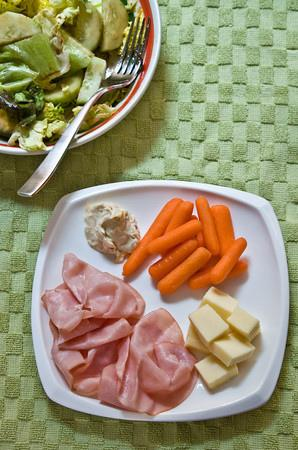Which corner of the plate contains meat?

Choices:
A) top right
B) bottom left
C) bottom right
D) top left bottom left 